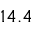<formula> <loc_0><loc_0><loc_500><loc_500>1 4 . 4</formula> 